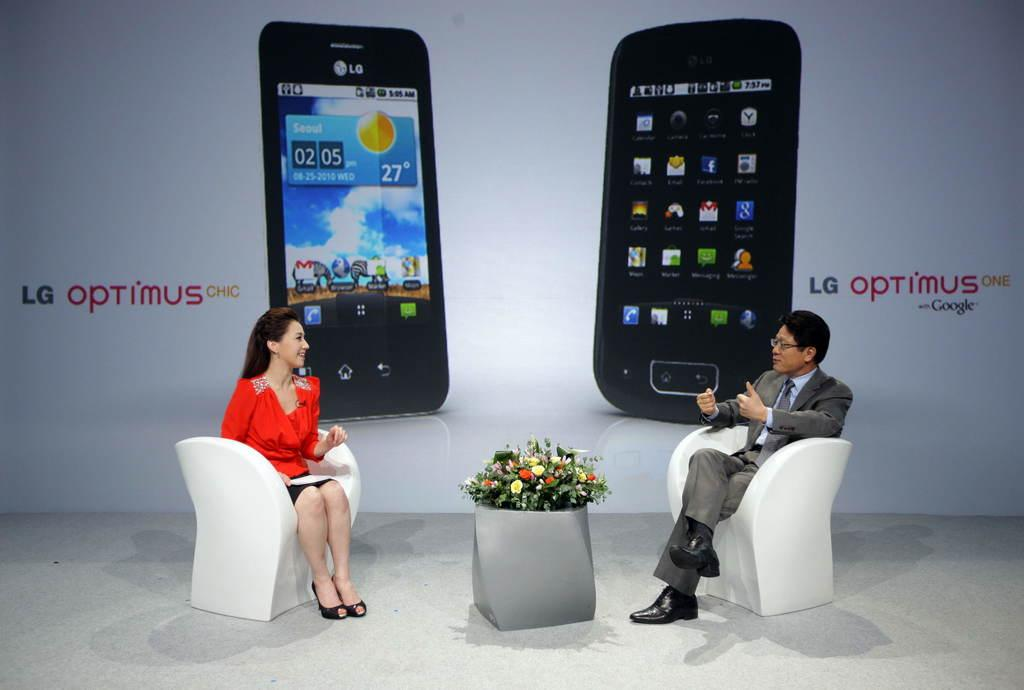<image>
Provide a brief description of the given image. Two people seated in white chairs discuss the LG Optimus. 